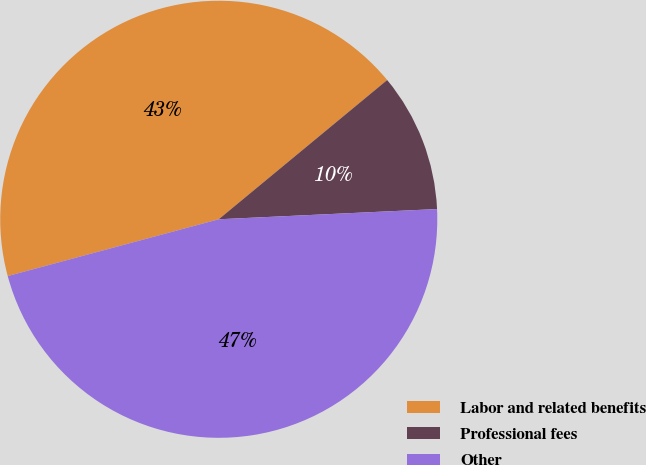<chart> <loc_0><loc_0><loc_500><loc_500><pie_chart><fcel>Labor and related benefits<fcel>Professional fees<fcel>Other<nl><fcel>43.19%<fcel>10.25%<fcel>46.56%<nl></chart> 